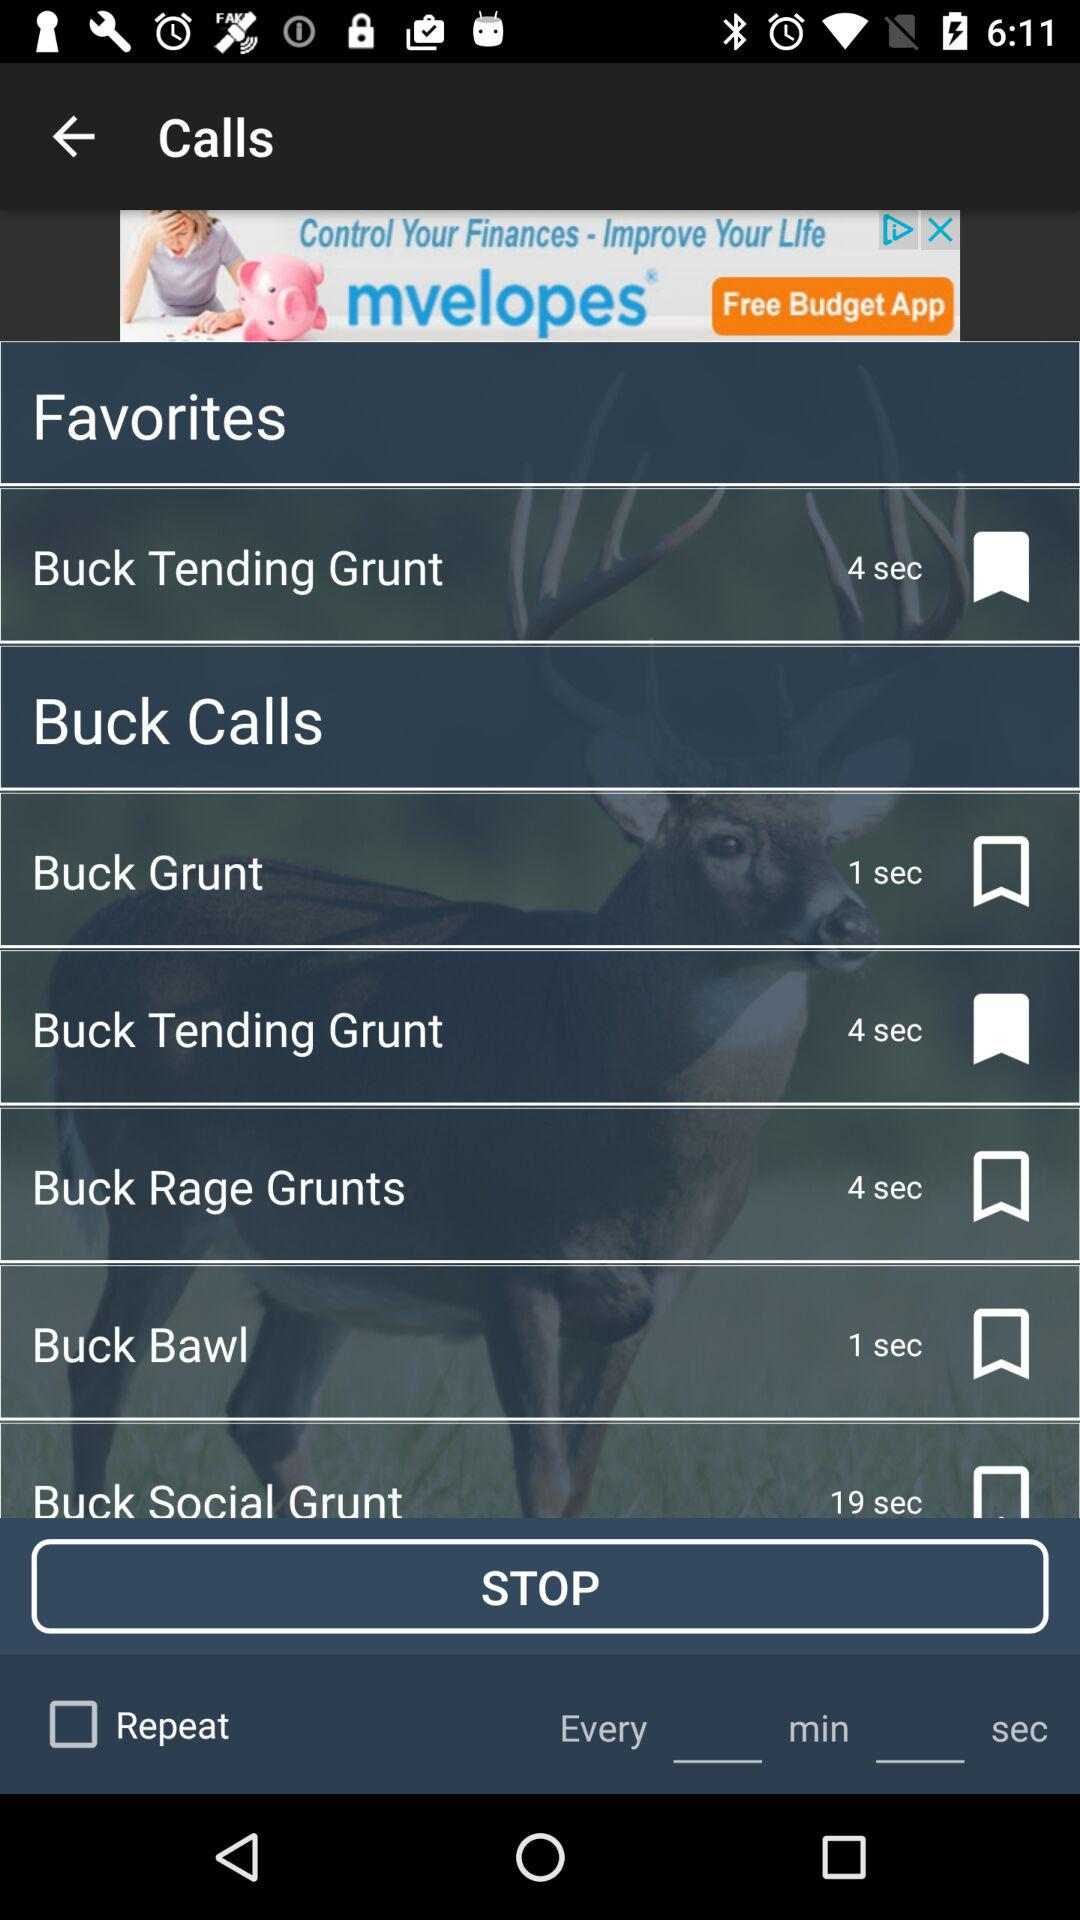Is "Repeat" checked or unchecked?
Answer the question using a single word or phrase. "Repeat" is unchecked. 